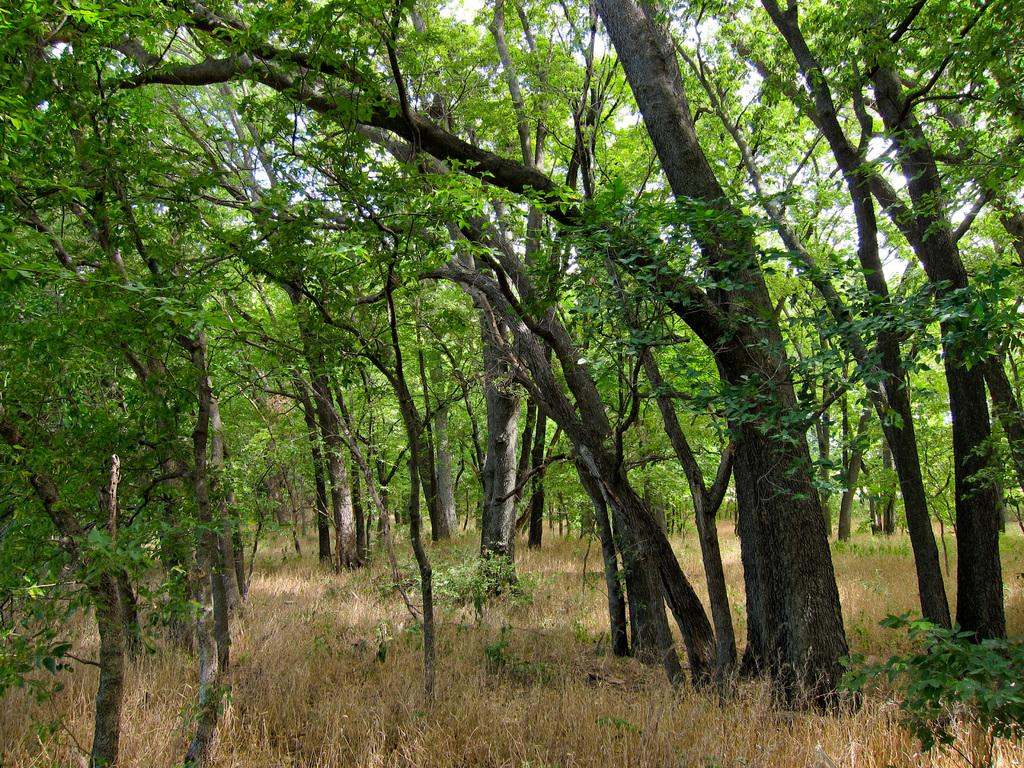What type of environment is depicted in the image? The image is likely taken in a forest. What can be seen among the trees in the image? There is a group of trees in the image. What type of vegetation is visible on the ground? There is grass visible in the image. What other types of vegetation can be seen in the image? There are plants present in the image. What month is it in the image? The month cannot be determined from the image, as there is no information about the time of year. What type of marble is present in the image? There is no marble present in the image; it features a forest setting with trees, grass, and plants. 